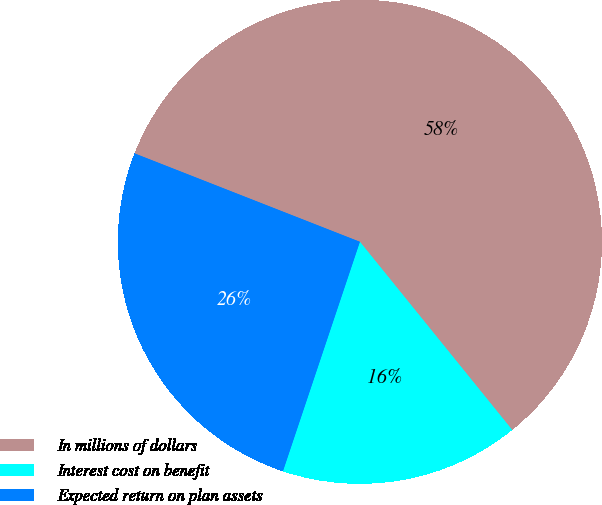<chart> <loc_0><loc_0><loc_500><loc_500><pie_chart><fcel>In millions of dollars<fcel>Interest cost on benefit<fcel>Expected return on plan assets<nl><fcel>58.22%<fcel>15.98%<fcel>25.8%<nl></chart> 